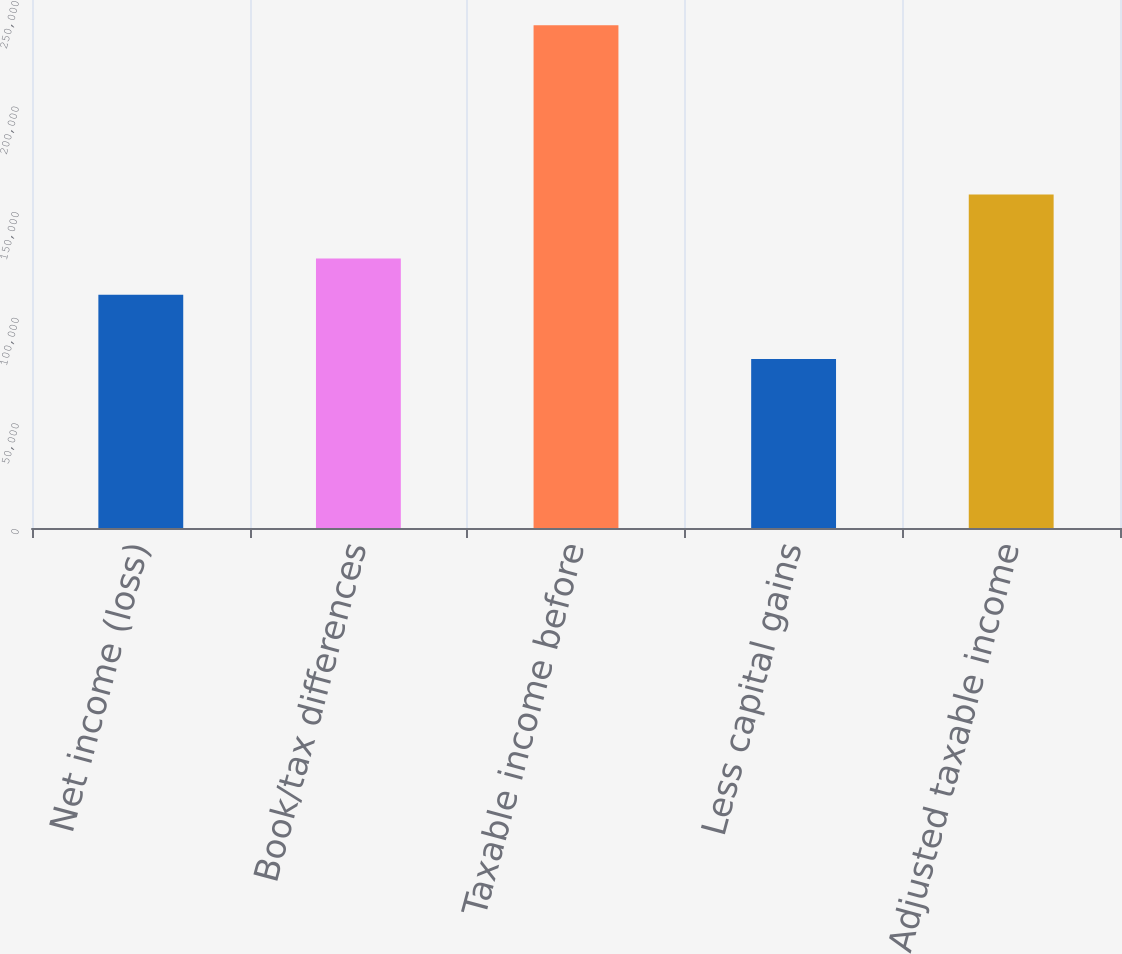Convert chart to OTSL. <chart><loc_0><loc_0><loc_500><loc_500><bar_chart><fcel>Net income (loss)<fcel>Book/tax differences<fcel>Taxable income before<fcel>Less capital gains<fcel>Adjusted taxable income<nl><fcel>110408<fcel>127607<fcel>238015<fcel>80069<fcel>157946<nl></chart> 